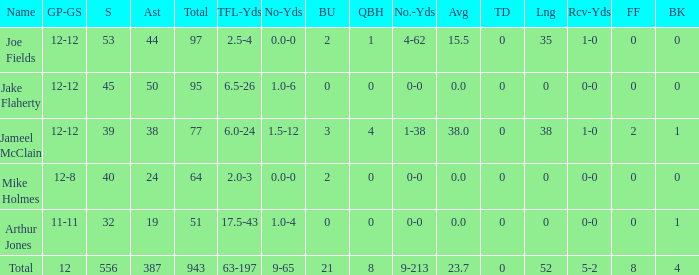How many tackle assists for the player who averages 23.7? 387.0. 